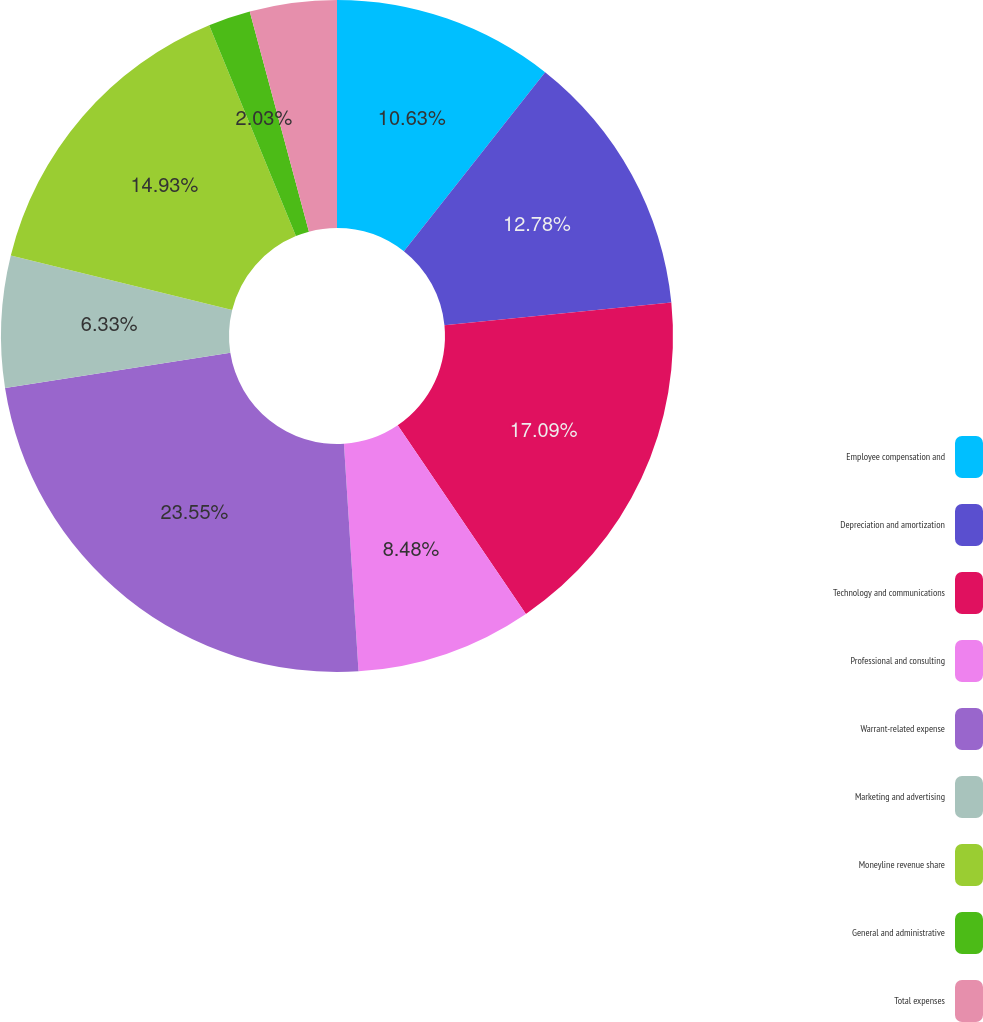<chart> <loc_0><loc_0><loc_500><loc_500><pie_chart><fcel>Employee compensation and<fcel>Depreciation and amortization<fcel>Technology and communications<fcel>Professional and consulting<fcel>Warrant-related expense<fcel>Marketing and advertising<fcel>Moneyline revenue share<fcel>General and administrative<fcel>Total expenses<nl><fcel>10.63%<fcel>12.78%<fcel>17.08%<fcel>8.48%<fcel>23.54%<fcel>6.33%<fcel>14.93%<fcel>2.03%<fcel>4.18%<nl></chart> 